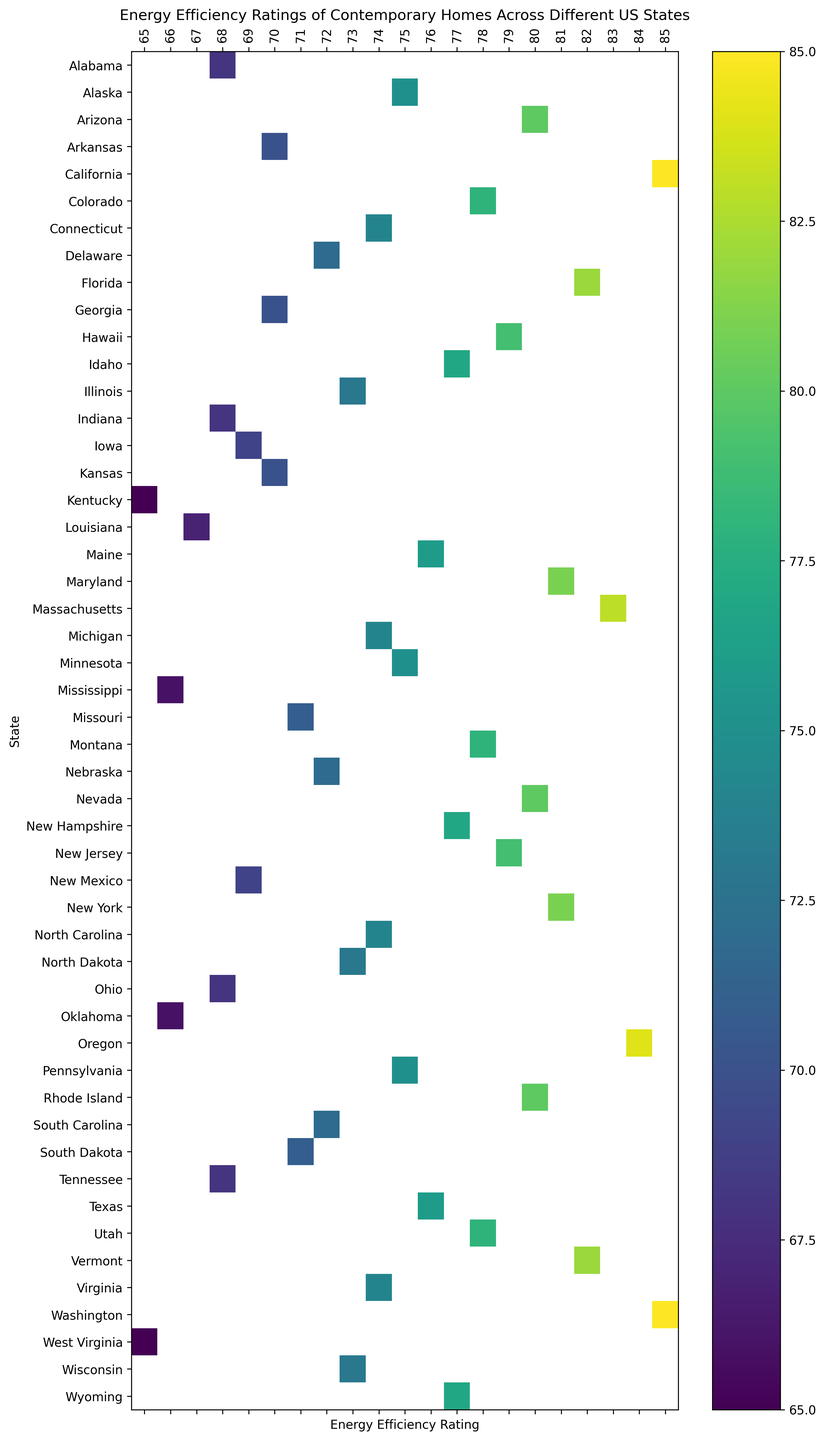What is the average energy efficiency rating across all states? To find the average, sum all ratings then divide by the number of states. The sum is 3825 and there are 50 states. So the average is 3825/50 = 76.5
Answer: 76.5 Which state has the highest energy efficiency rating? Look for the state with the darkest color, indicating the highest rating. California and Washington, with a rating of 85, are the highest.
Answer: California and Washington Which state has the lowest energy efficiency rating? Look for the state with the lightest color, indicating the lowest rating. West Virginia, with a rating of 65, is the lowest.
Answer: West Virginia How many states have an energy efficiency rating greater than 80? Count the states that have a color corresponding to ratings above 80. There are 8 states: California, Florida, Maryland, Massachusetts, New York, Oregon, Vermont, and Washington.
Answer: 8 Compare the energy efficiency ratings of Alabama and Alaska. Alabama has a rating of 68, while Alaska has a rating of 75. Alaska’s rating is higher.
Answer: Alaska What is the difference in energy efficiency rating between Georgia and Kentucky? Subtract Kentucky's rating (65) from Georgia's rating (70). The difference is 70 - 65 = 5.
Answer: 5 What is the median energy efficiency rating? Arrange all 50 ratings in numerical order and find the middle value. The 25th and 26th values are 73, so the median is 73.
Answer: 73 Which regions (Northeast, Midwest, South, West) generally have higher ratings? Compare regions: Northeast (74-83), Midwest (66-77), South (65-82), West (75-85). The West generally has higher ratings.
Answer: West How does the rating of Florida compare to the median rating? Florida's rating is 82, and the median is 73. Florida's rating is higher than the median.
Answer: Higher What is the range of energy efficiency ratings across all states? Find the difference between the highest (85) and lowest (65) ratings. The range is 85 - 65 = 20.
Answer: 20 